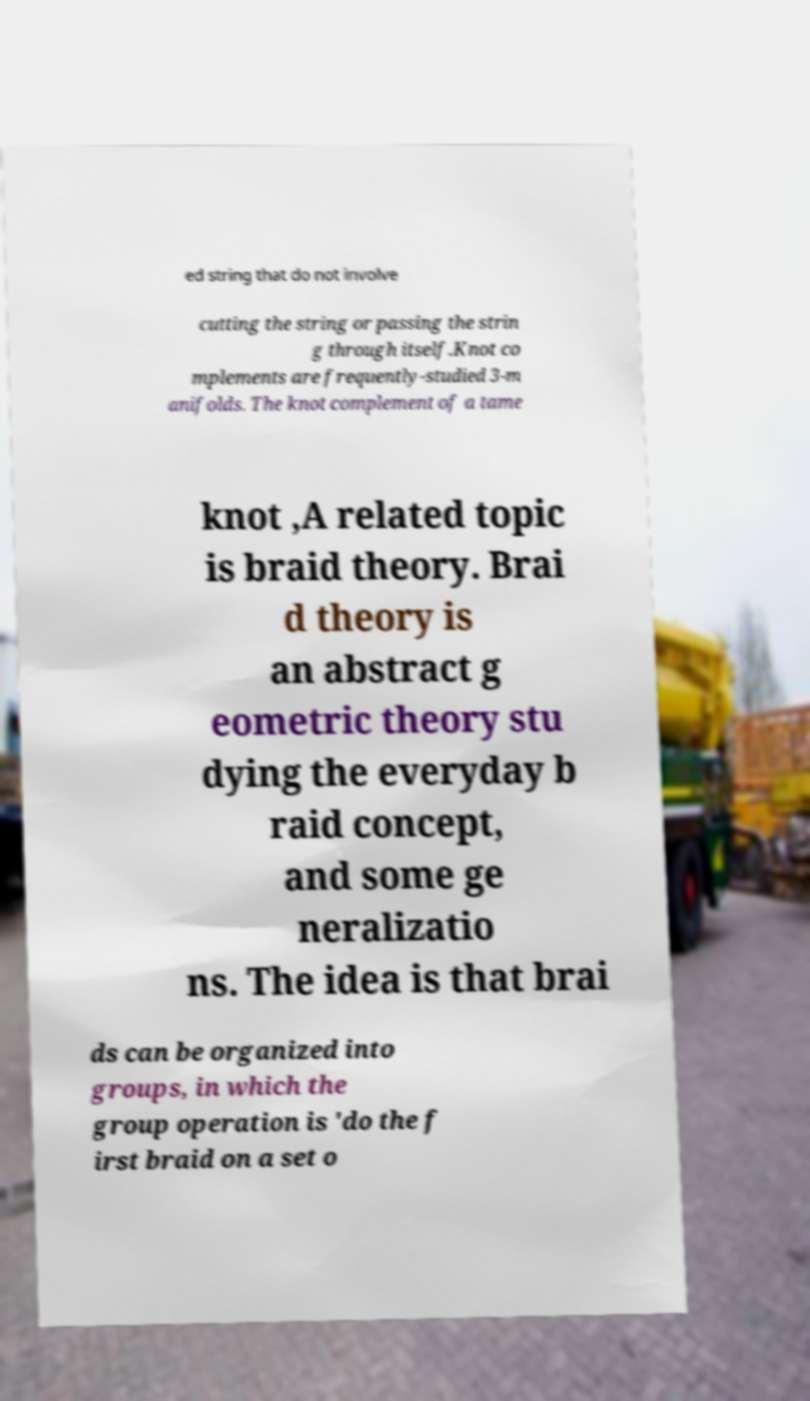Could you extract and type out the text from this image? ed string that do not involve cutting the string or passing the strin g through itself.Knot co mplements are frequently-studied 3-m anifolds. The knot complement of a tame knot ,A related topic is braid theory. Brai d theory is an abstract g eometric theory stu dying the everyday b raid concept, and some ge neralizatio ns. The idea is that brai ds can be organized into groups, in which the group operation is 'do the f irst braid on a set o 